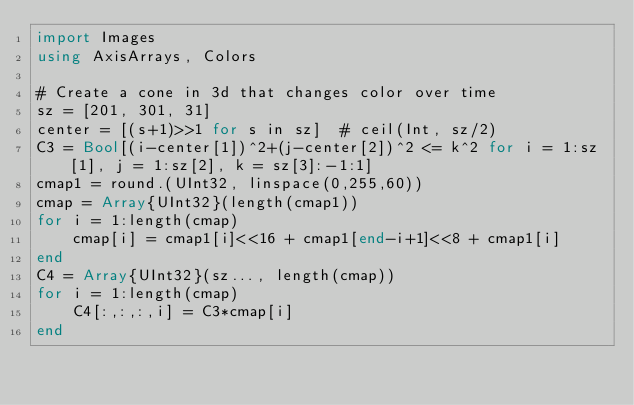Convert code to text. <code><loc_0><loc_0><loc_500><loc_500><_Julia_>import Images
using AxisArrays, Colors

# Create a cone in 3d that changes color over time
sz = [201, 301, 31]
center = [(s+1)>>1 for s in sz]  # ceil(Int, sz/2)
C3 = Bool[(i-center[1])^2+(j-center[2])^2 <= k^2 for i = 1:sz[1], j = 1:sz[2], k = sz[3]:-1:1]
cmap1 = round.(UInt32, linspace(0,255,60))
cmap = Array{UInt32}(length(cmap1))
for i = 1:length(cmap)
    cmap[i] = cmap1[i]<<16 + cmap1[end-i+1]<<8 + cmap1[i]
end
C4 = Array{UInt32}(sz..., length(cmap))
for i = 1:length(cmap)
    C4[:,:,:,i] = C3*cmap[i]
end</code> 